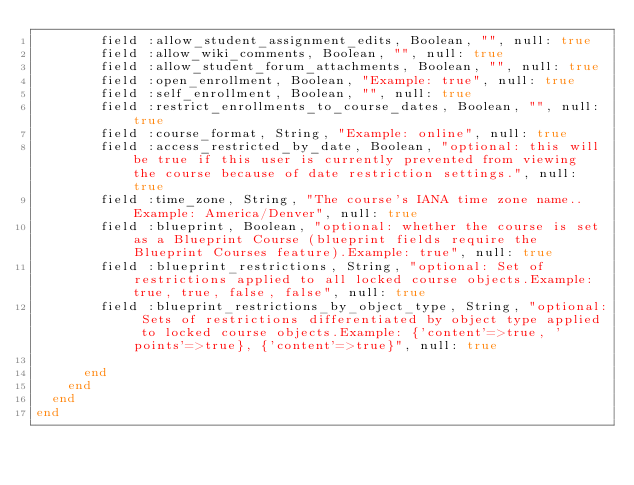<code> <loc_0><loc_0><loc_500><loc_500><_Ruby_>        field :allow_student_assignment_edits, Boolean, "", null: true
        field :allow_wiki_comments, Boolean, "", null: true
        field :allow_student_forum_attachments, Boolean, "", null: true
        field :open_enrollment, Boolean, "Example: true", null: true
        field :self_enrollment, Boolean, "", null: true
        field :restrict_enrollments_to_course_dates, Boolean, "", null: true
        field :course_format, String, "Example: online", null: true
        field :access_restricted_by_date, Boolean, "optional: this will be true if this user is currently prevented from viewing the course because of date restriction settings.", null: true
        field :time_zone, String, "The course's IANA time zone name..Example: America/Denver", null: true
        field :blueprint, Boolean, "optional: whether the course is set as a Blueprint Course (blueprint fields require the Blueprint Courses feature).Example: true", null: true
        field :blueprint_restrictions, String, "optional: Set of restrictions applied to all locked course objects.Example: true, true, false, false", null: true
        field :blueprint_restrictions_by_object_type, String, "optional: Sets of restrictions differentiated by object type applied to locked course objects.Example: {'content'=>true, 'points'=>true}, {'content'=>true}", null: true

      end
    end
  end
end</code> 